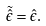<formula> <loc_0><loc_0><loc_500><loc_500>\tilde { \hat { \epsilon } } = \hat { \epsilon } .</formula> 